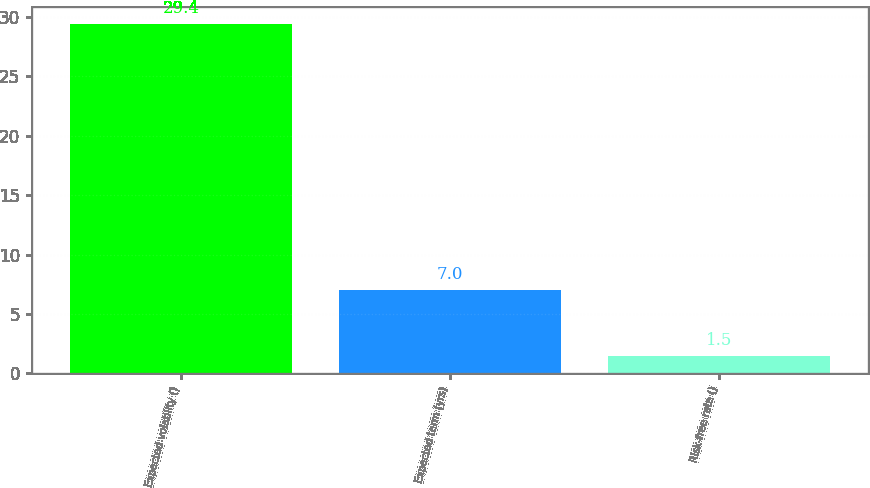Convert chart to OTSL. <chart><loc_0><loc_0><loc_500><loc_500><bar_chart><fcel>Expected volatility ()<fcel>Expected term (yrs)<fcel>Risk-free rate ()<nl><fcel>29.4<fcel>7<fcel>1.5<nl></chart> 